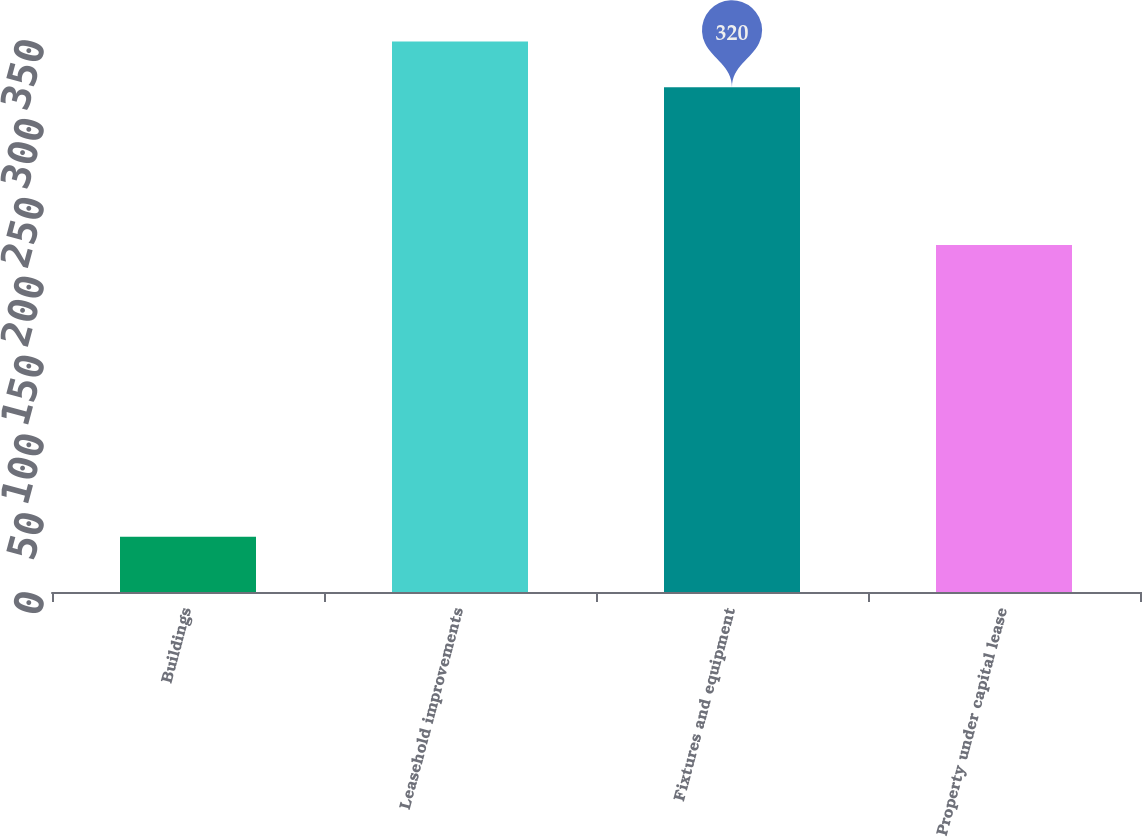Convert chart to OTSL. <chart><loc_0><loc_0><loc_500><loc_500><bar_chart><fcel>Buildings<fcel>Leasehold improvements<fcel>Fixtures and equipment<fcel>Property under capital lease<nl><fcel>35<fcel>349<fcel>320<fcel>220<nl></chart> 